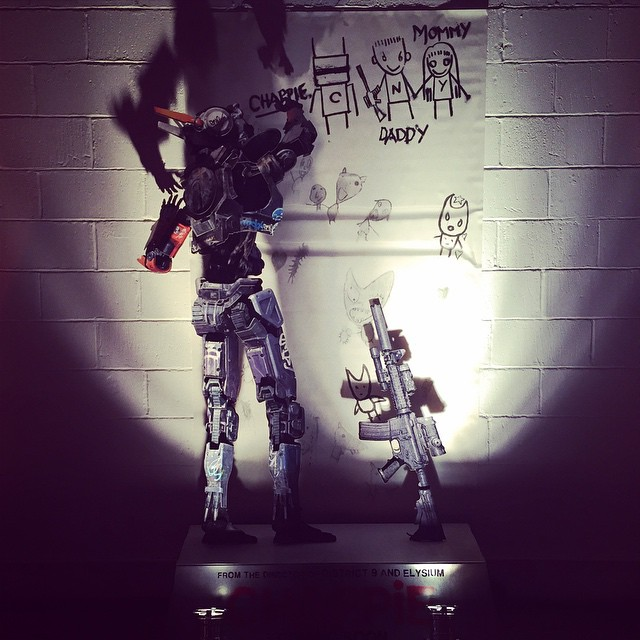Imagine this robot is featured in a science fiction story. What could be its backstory and main quest? In a science fiction story, this robot could have a backstory as a highly advanced defense unit created in a post-apocalyptic world where humanity is striving to rebuild its society. Its main quest might involve protecting a small group of surviving human children who represent the future hope for rebuilding civilization. It could be equipped with both combat abilities to fend off threats and the capacity to nurture and educate the children. Along the way, the robot might grapple with understanding human emotions and developing its own sense of identity and purpose, leading to a poignant exploration of what it means to be alive and the intertwining of artificial intelligence with human values and emotions. 